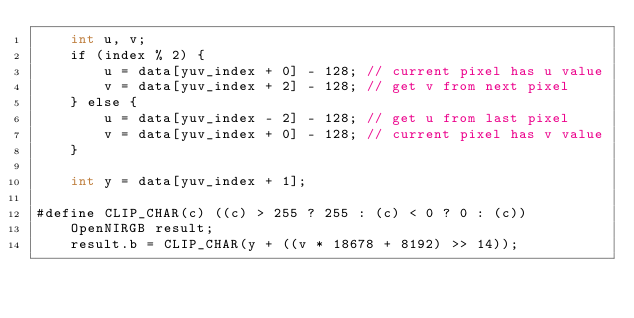<code> <loc_0><loc_0><loc_500><loc_500><_Cuda_>    int u, v;
    if (index % 2) {
        u = data[yuv_index + 0] - 128; // current pixel has u value
        v = data[yuv_index + 2] - 128; // get v from next pixel
    } else {
        u = data[yuv_index - 2] - 128; // get u from last pixel
        v = data[yuv_index + 0] - 128; // current pixel has v value
    }

    int y = data[yuv_index + 1];

#define CLIP_CHAR(c) ((c) > 255 ? 255 : (c) < 0 ? 0 : (c))
    OpenNIRGB result;
    result.b = CLIP_CHAR(y + ((v * 18678 + 8192) >> 14));</code> 